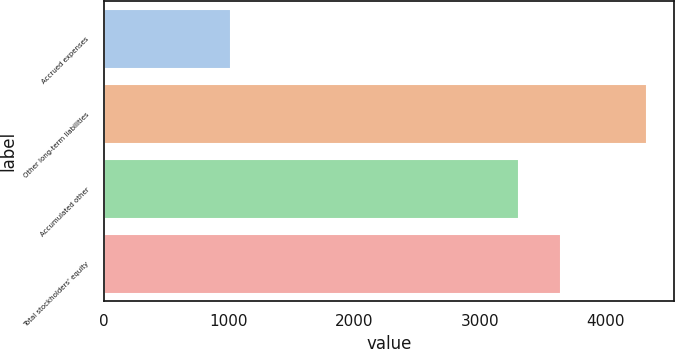<chart> <loc_0><loc_0><loc_500><loc_500><bar_chart><fcel>Accrued expenses<fcel>Other long-term liabilities<fcel>Accumulated other<fcel>Total stockholders' equity<nl><fcel>1020<fcel>4336<fcel>3316<fcel>3647.6<nl></chart> 